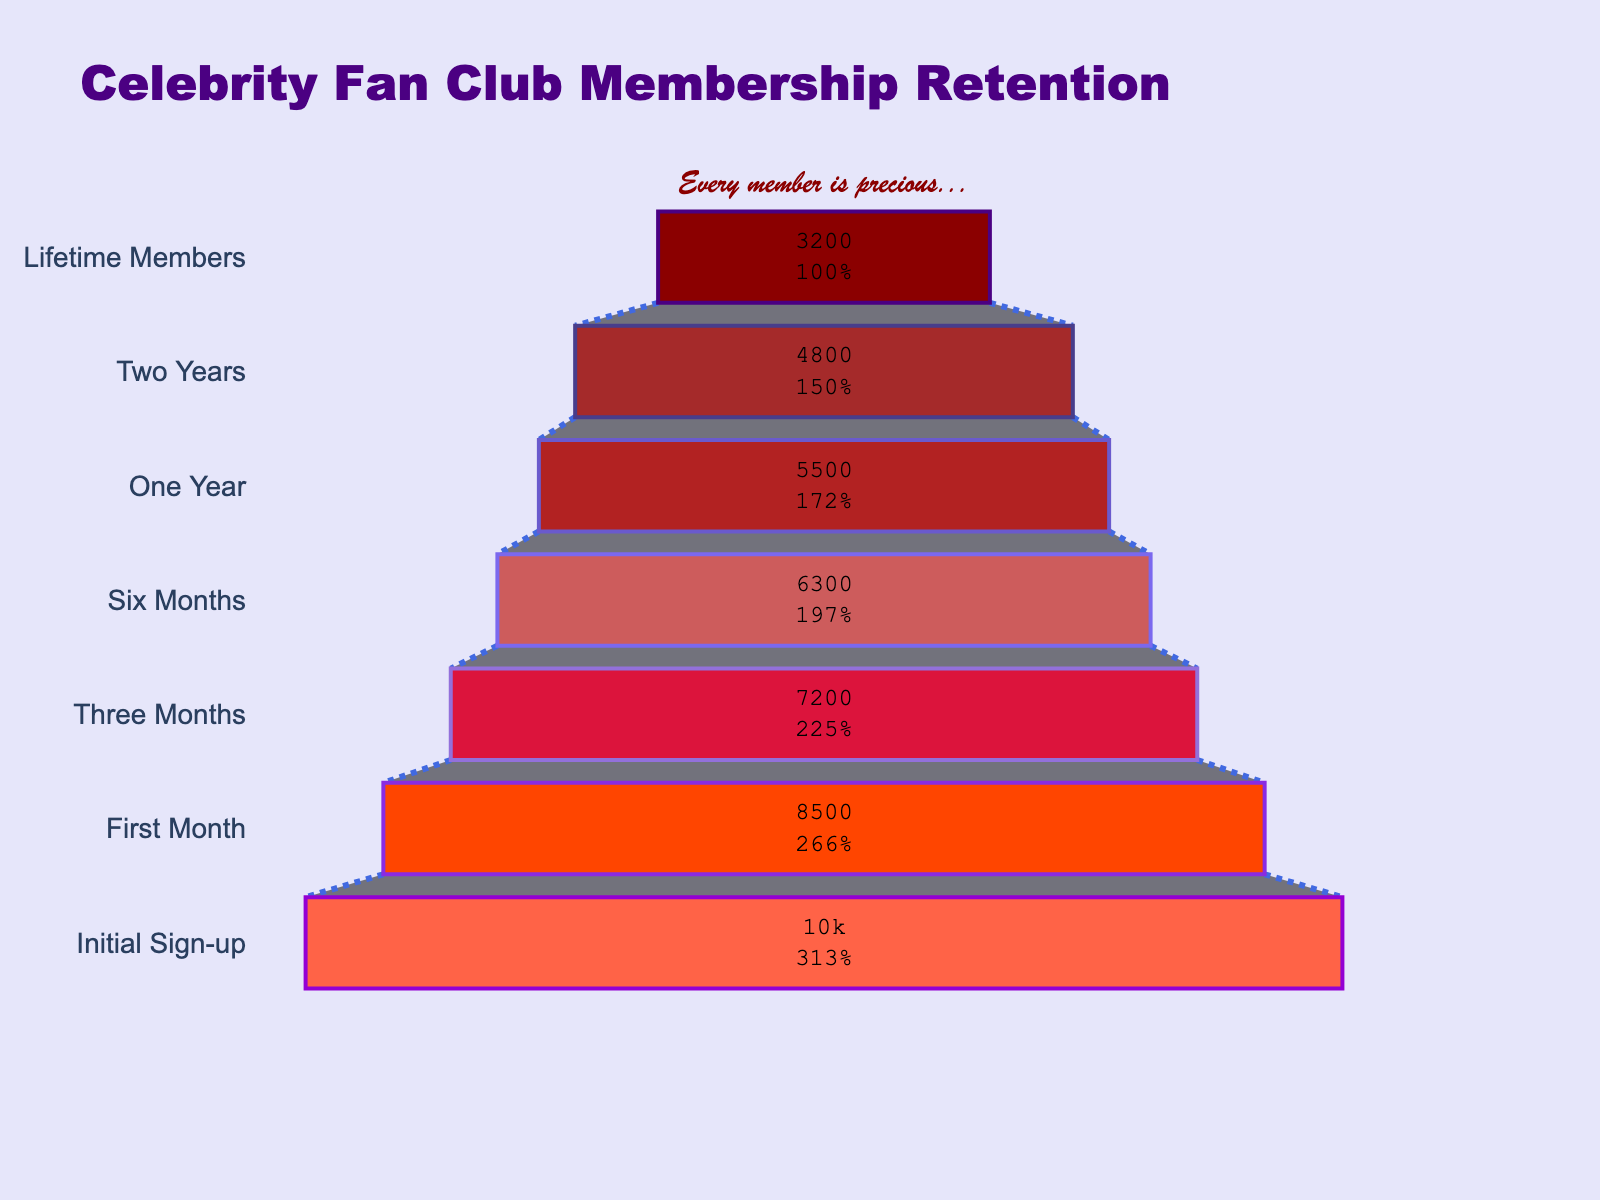How many members signed up initially? The title of the funnel chart is "Celebrity Fan Club Membership Retention," and the data indicates that the "Initial Sign-up" stage has 10,000 members.
Answer: 10,000 What percentage of the initial members remained after the first month? The "First Month" stage has 8,500 members, and the "Initial Sign-up" stage has 10,000 members. The percentage is calculated as (8500/10000) * 100.
Answer: 85% How many members did the fan club lose between the first month and three months? The "First Month" stage has 8,500 members, and the "Three Months" stage has 7,200 members. The number of members lost is calculated as 8500 - 7200.
Answer: 1,300 Which stage saw the smallest decrease in membership numbers? By comparing the membership numbers between consecutive stages, we find the smallest difference is between "Six Months" (6,300 members) and "One Year" (5,500 members), which is calculated as 6300 - 5500 = 800.
Answer: Six Months to One Year What is the trend of membership retention over time? The funnel chart shows a decreasing trend in membership numbers as we move from "Initial Sign-up" to "Lifetime Members," indicating a gradual decline in member retention over time.
Answer: Decreasing trend How many members are classified as "Lifetime Members"? The "Lifetime Members" stage shows that there are 3,200 members at this stage.
Answer: 3,200 By what percentage does the membership drop from one year to two years? The "One Year" stage has 5,500 members and the "Two Years" stage has 4,800 members. The percentage drop is calculated as ((5500 - 4800) / 5500) * 100.
Answer: 12.7% Which two stages have the biggest difference in membership numbers? By comparing the differences between each pair of consecutive stages, the largest decrease is from "Initial Sign-up" (10,000 members) to "First Month" (8,500 members), which is 10,000 - 8,500 = 1,500.
Answer: Initial Sign-up to First Month What is the total loss in membership from Initial Sign-up to Lifetime Members? The "Initial Sign-up" stage has 10,000 members and the "Lifetime Members" stage has 3,200 members. The total loss in membership is calculated as 10,000 - 3,200.
Answer: 6,800 